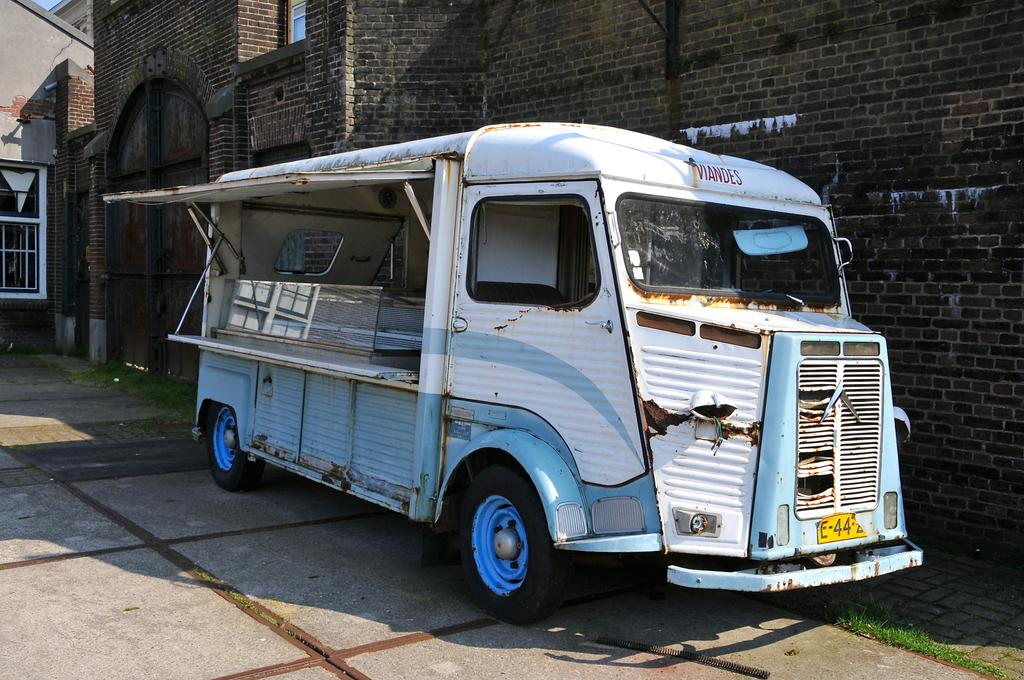What is the main subject in the center of the image? There is an old van in the center of the image. What can be seen in the background of the image? There is a building in the background of the image. Where is the window located in the image? There is a window on the left side of the image. What type of powder is being used for dinner in the image? There is no dinner or powder present in the image; it features an old van and a building in the background. 